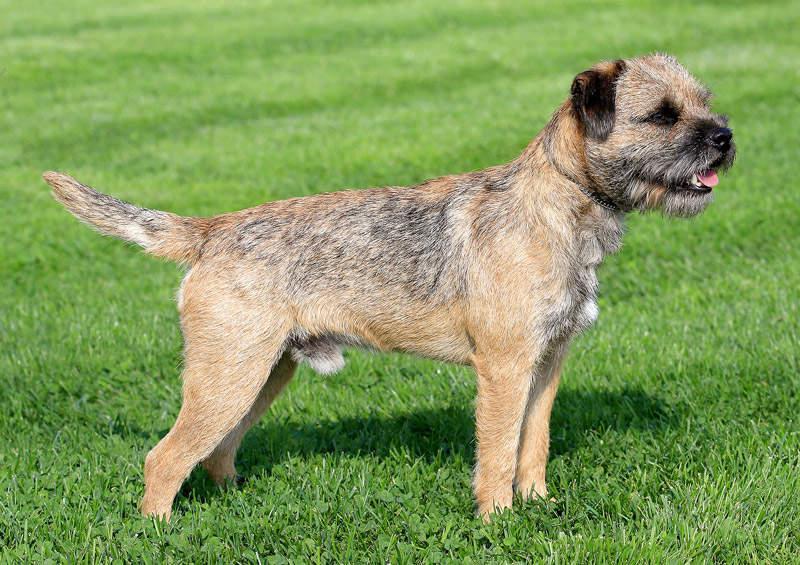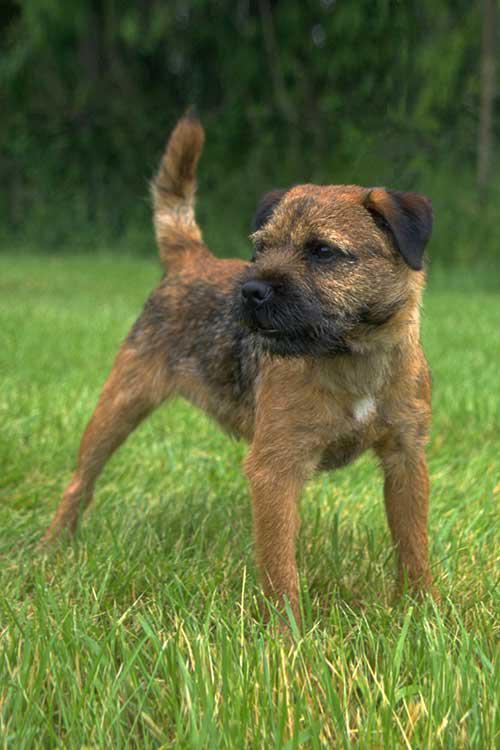The first image is the image on the left, the second image is the image on the right. Examine the images to the left and right. Is the description "The left and right image contains the same number of dogs with at least one sitting in grass." accurate? Answer yes or no. No. The first image is the image on the left, the second image is the image on the right. Considering the images on both sides, is "At least two dogs are standing." valid? Answer yes or no. Yes. 